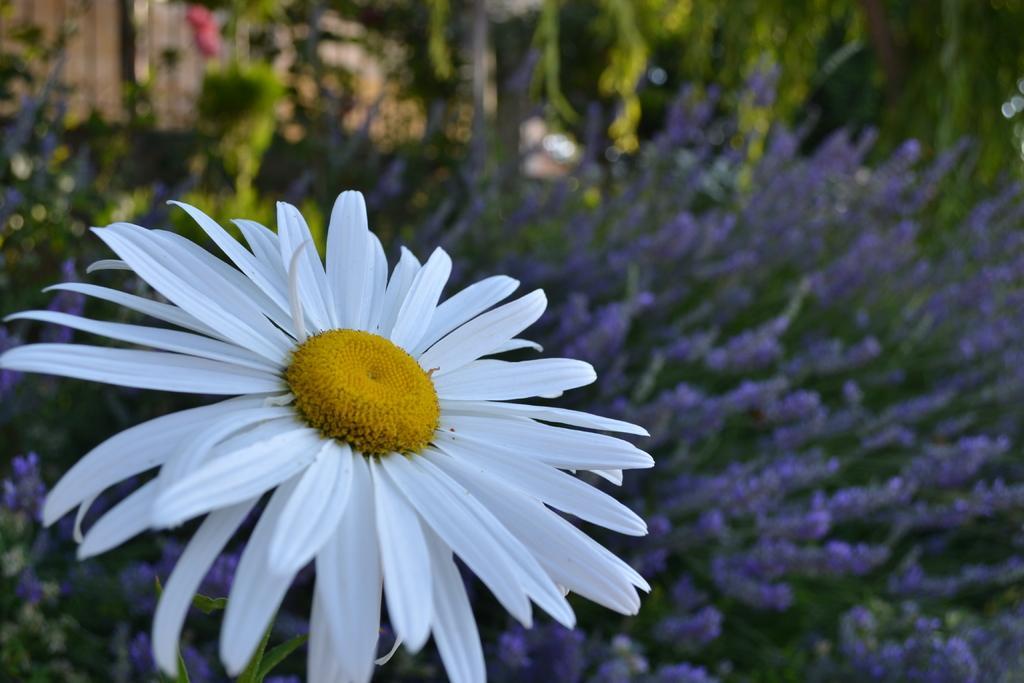Describe this image in one or two sentences. In this image in the foreground there is a white flower, and in the background there are some flowers and plants. 